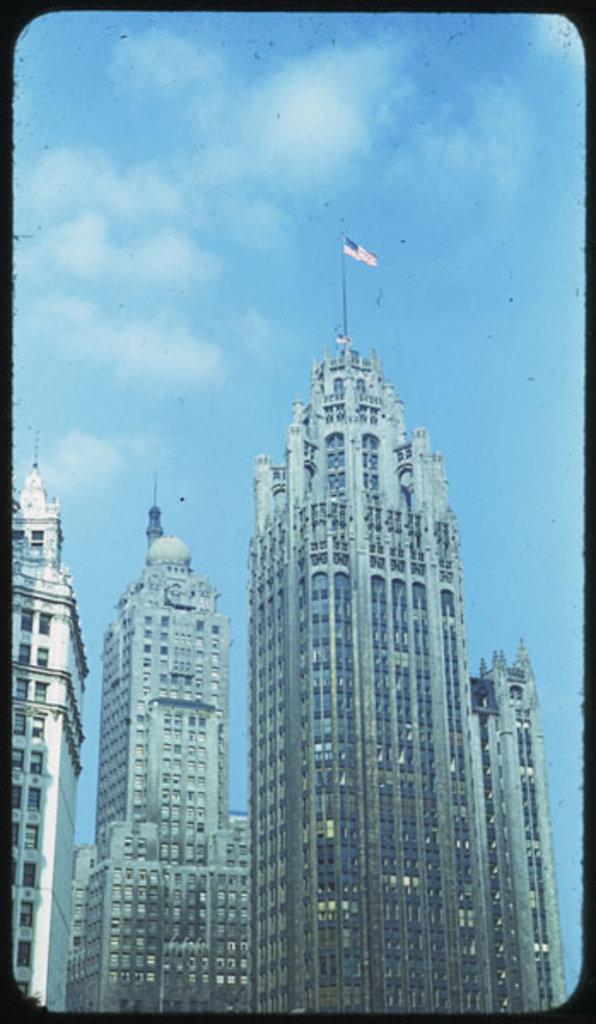What type of buildings can be seen in the image? There are skyscrapers in the image. How would you describe the sky in the image? The sky is blue and slightly cloudy in the image. Can you identify any specific features on the skyscrapers? Yes, there is a USA flag on one of the skyscrapers. What type of pancake is being served at the police station in the image? There is no pancake or police station present in the image. What type of cloth is draped over the skyscraper in the image? There is no cloth draped over any skyscraper in the image; only the USA flag is visible. 